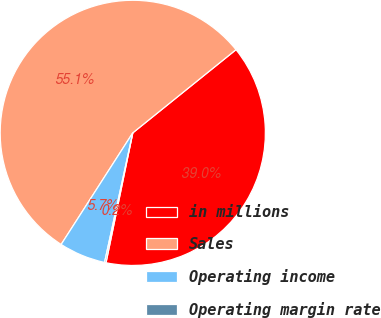<chart> <loc_0><loc_0><loc_500><loc_500><pie_chart><fcel>in millions<fcel>Sales<fcel>Operating income<fcel>Operating margin rate<nl><fcel>39.03%<fcel>55.12%<fcel>5.67%<fcel>0.18%<nl></chart> 